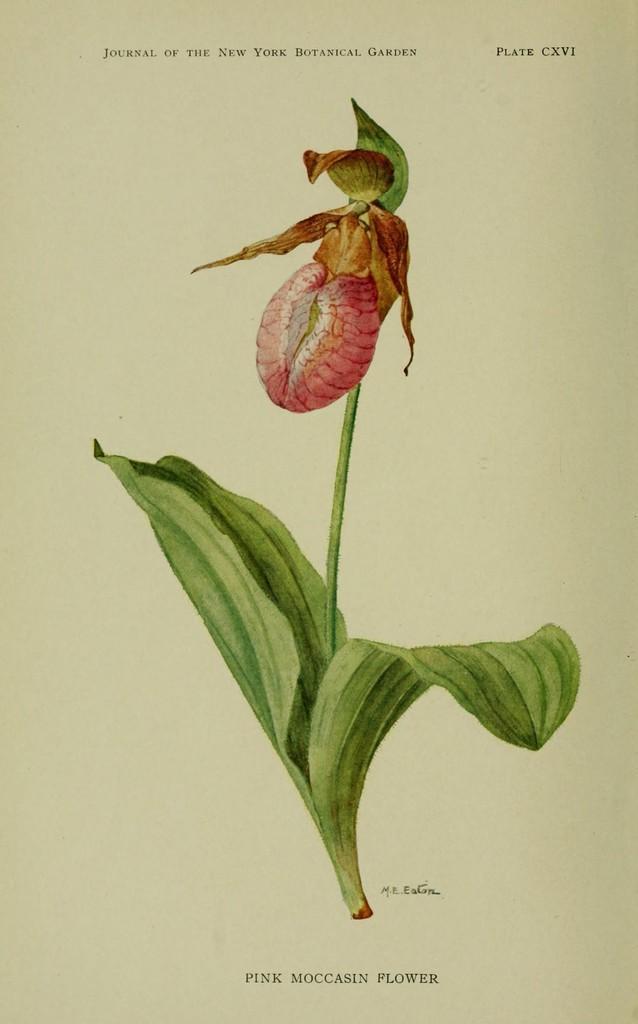Can you describe this image briefly? In this Image I can see a red color flower and few leaves on the paper and something is written on the paper. 